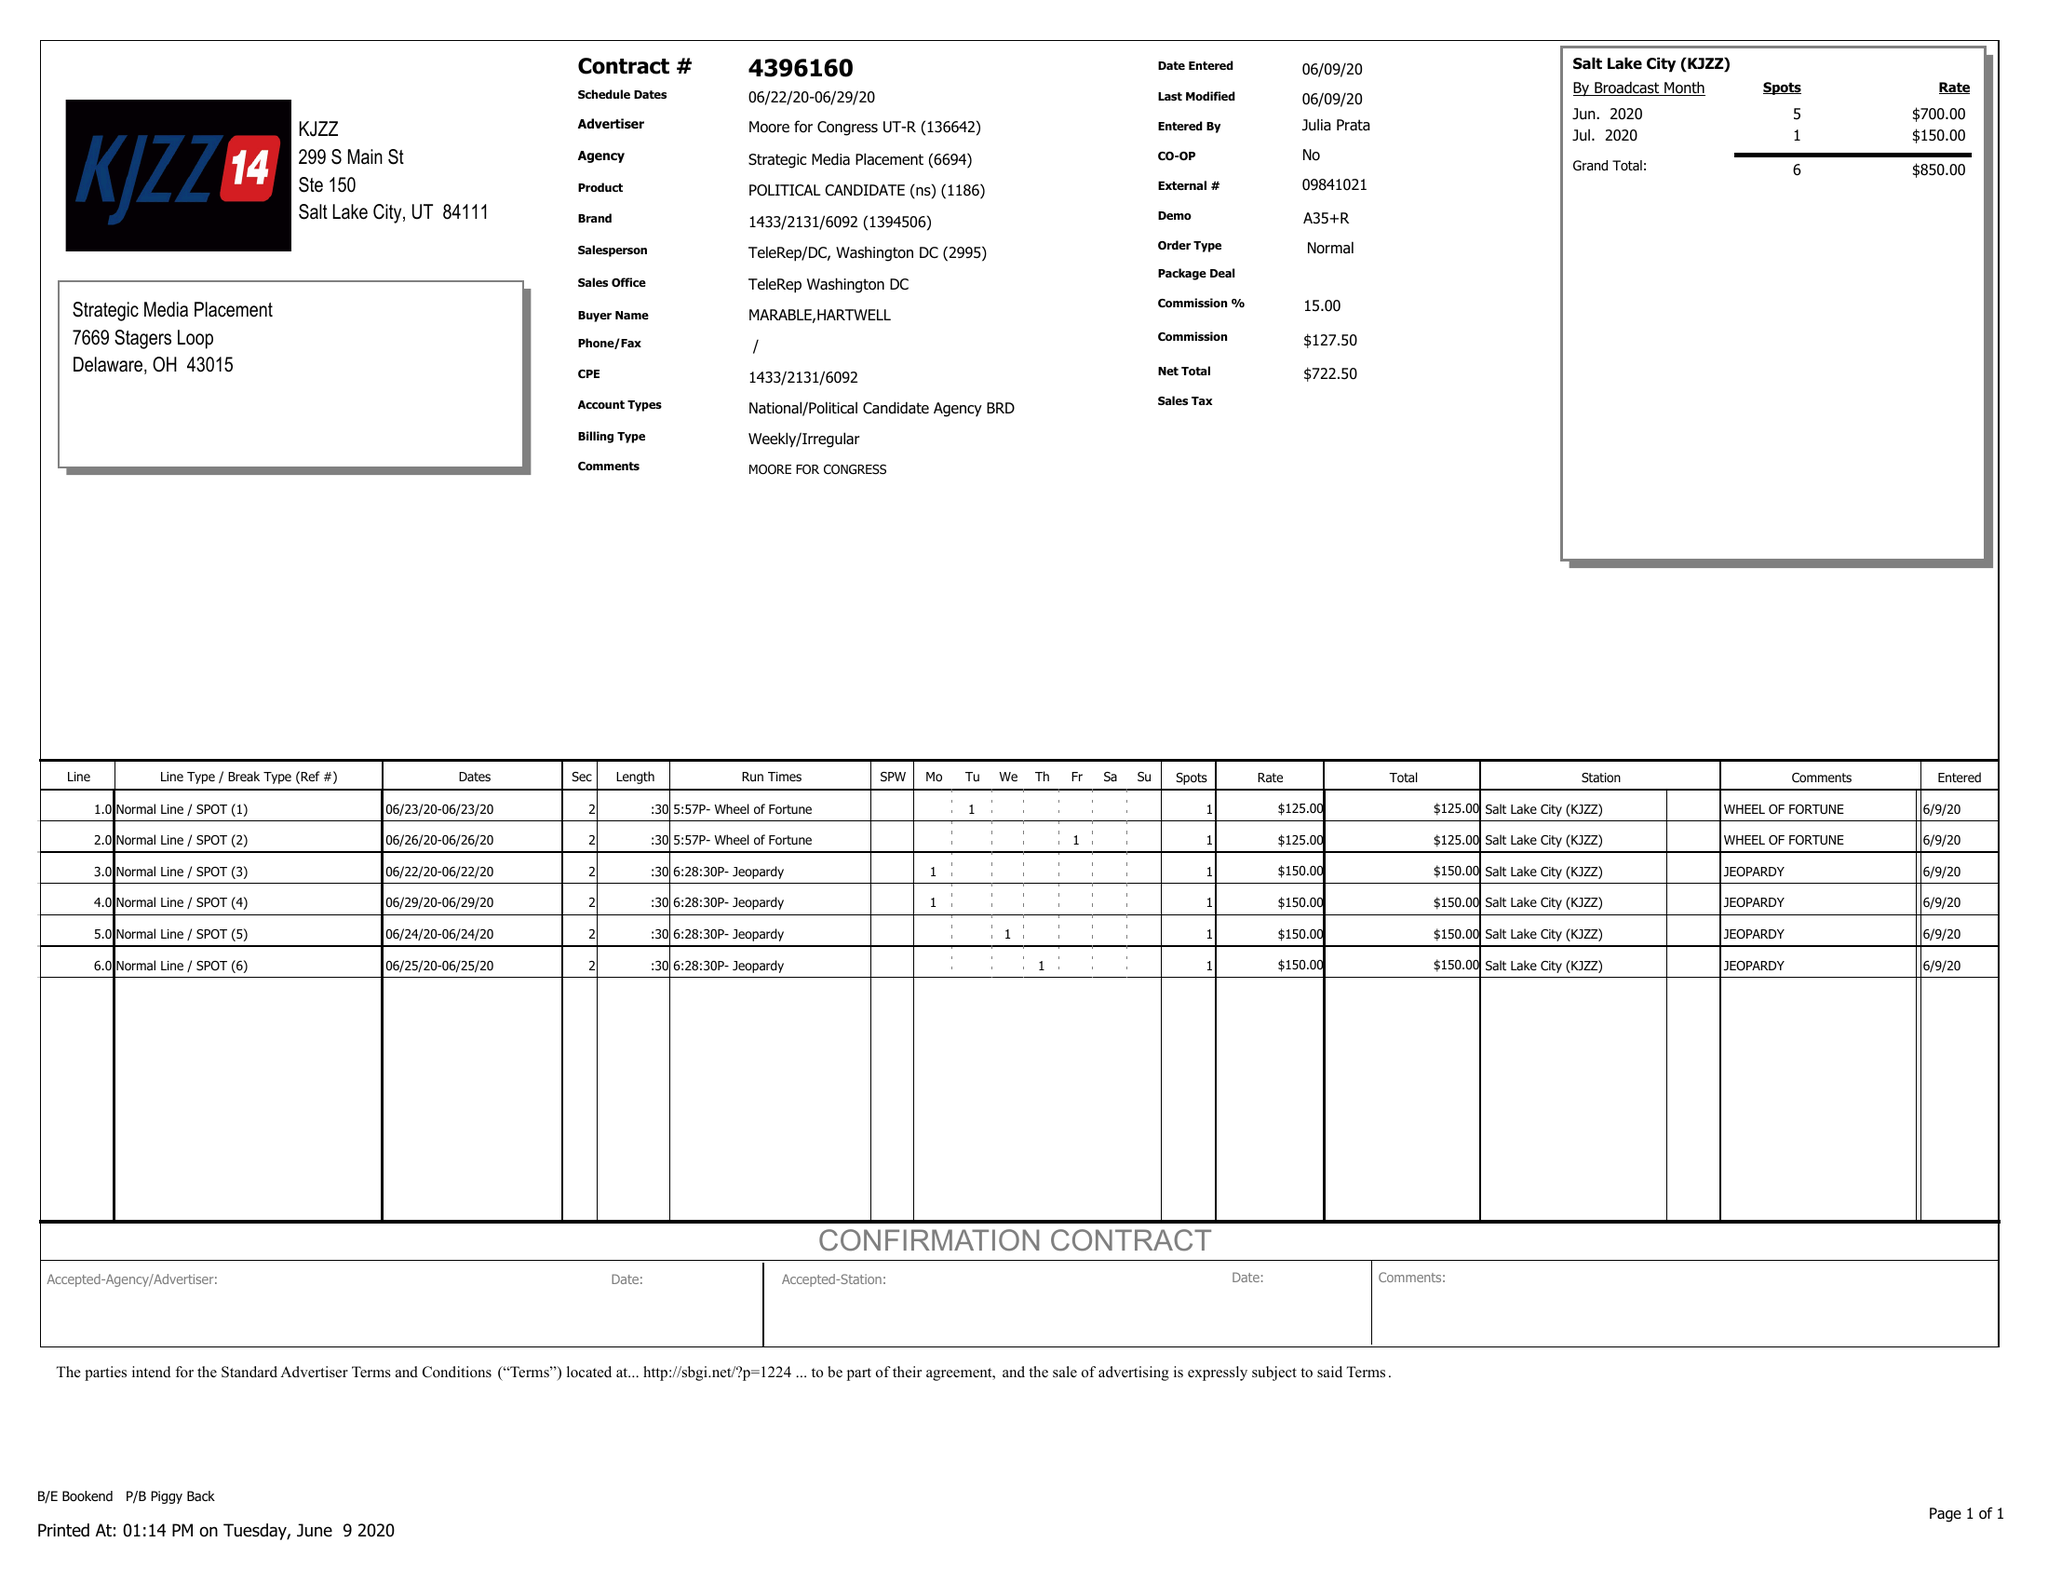What is the value for the flight_from?
Answer the question using a single word or phrase. 06/22/20 